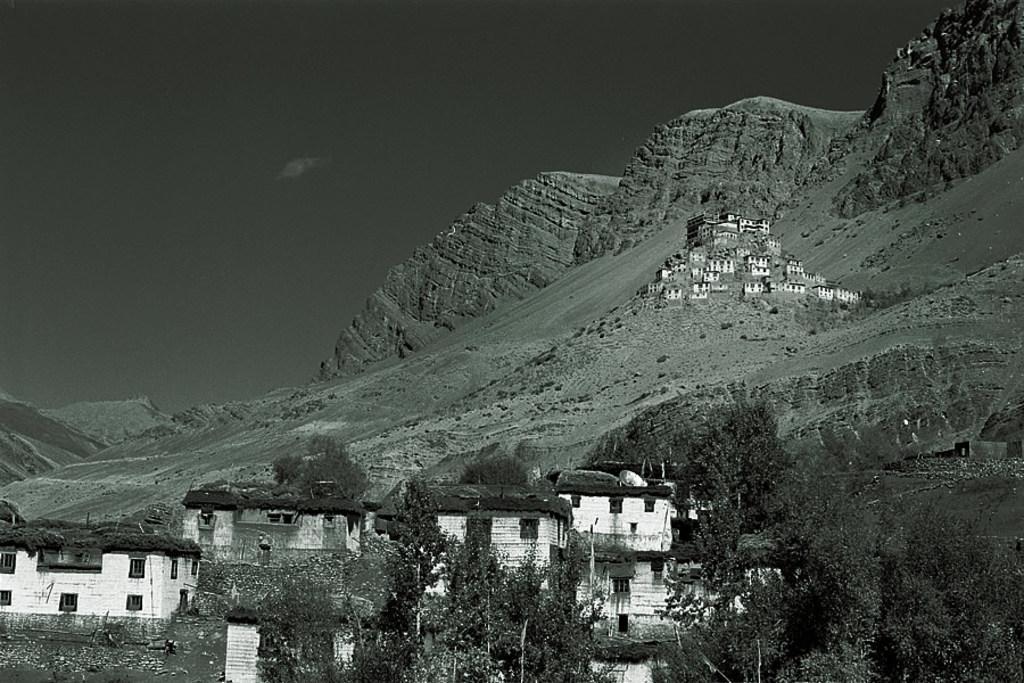Could you give a brief overview of what you see in this image? This is an edited image. In this picture, we see the trees, buildings and poles. On the right side, we see the hills and the buildings in white color. There are hills in the background. At the top, we see the sky. 